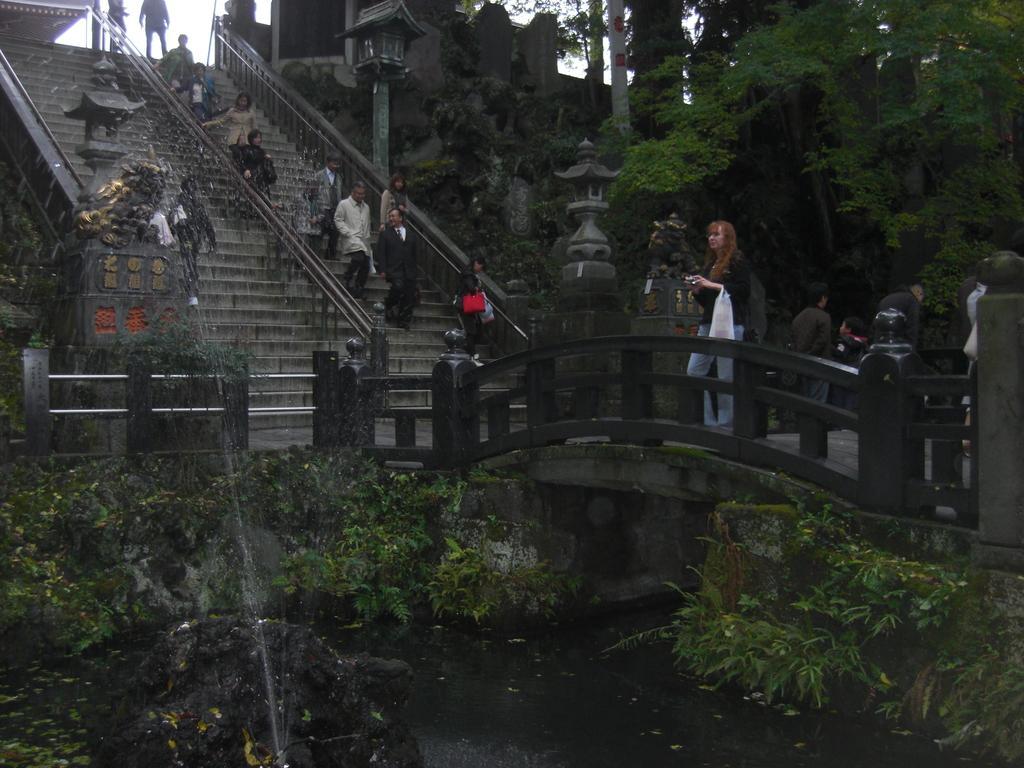How would you summarize this image in a sentence or two? In this picture we can see water at the bottom, there are some plants in the front, on the right side there is a bridge, we can see stairs in the middle, there are some people on the stairs, on the right side we can see a tree, we can also see a light in the middle, we can see the sky at the top of the picture. 